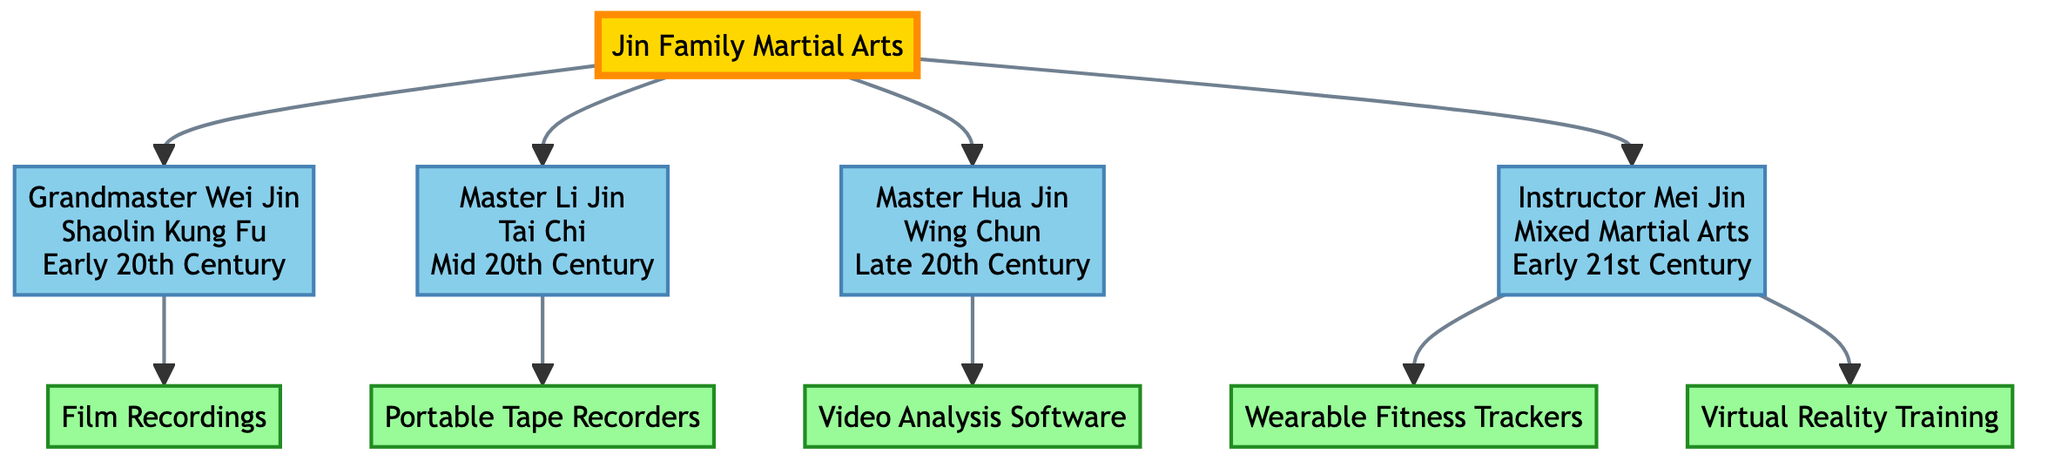What martial art does Grandmaster Wei Jin practice? Grandmaster Wei Jin is listed directly under the Jin Family Martial Arts tree as practicing Shaolin Kung Fu. This is indicated in the section connected to his node.
Answer: Shaolin Kung Fu How many technological innovations are listed for Master Li Jin? Master Li Jin has one technological innovation associated with him, which is the Portable Tape Recorders. This can be confirmed by examining the innovations connected to his node.
Answer: 1 Who trained in Mixed Martial Arts during the early 21st Century? The node for Instructor Mei Jin clearly states that she practices Mixed Martial Arts and is located in the early 21st Century section.
Answer: Instructor Mei Jin What is the innovation associated with Master Hua Jin? The innovation listed for Master Hua Jin is Video Analysis Software, which is connected directly to his node in the diagram.
Answer: Video Analysis Software How many generations of martial artists are represented in the Jin family tree? The tree has one root node and four child nodes representing four generations of martial artists, including the root itself. Thus, the total is five generations.
Answer: 5 Which innovation is used to monitor physiological data in training? The innovation that is used to monitor physiological data is Wearable Fitness Trackers. It is specifically noted as one of the innovations listed under Instructor Mei Jin.
Answer: Wearable Fitness Trackers What era does Master Li Jin's practice belong to? Master Li Jin is noted to belong to the Mid 20th Century era, which is indicated alongside his name in the family tree.
Answer: Mid 20th Century Which family member utilized Virtual Reality Training? The innovation of Virtual Reality Training is specifically linked to Instructor Mei Jin, indicating her utilization of this technology in her training methods.
Answer: Instructor Mei Jin What is the relationship between the Jin Family and its members? The Jin Family is the root node, and its members, including Grandmaster Wei Jin, Master Li Jin, Master Hua Jin, and Instructor Mei Jin, are all child nodes stemming from it. This indicates a direct lineage relationship.
Answer: Parent-Child 